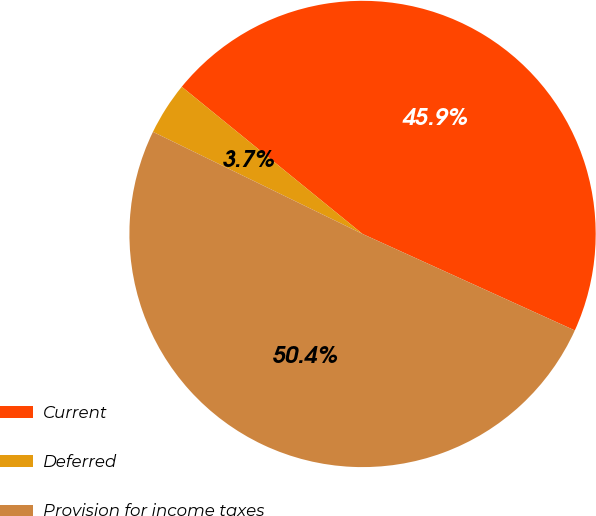Convert chart to OTSL. <chart><loc_0><loc_0><loc_500><loc_500><pie_chart><fcel>Current<fcel>Deferred<fcel>Provision for income taxes<nl><fcel>45.91%<fcel>3.66%<fcel>50.42%<nl></chart> 